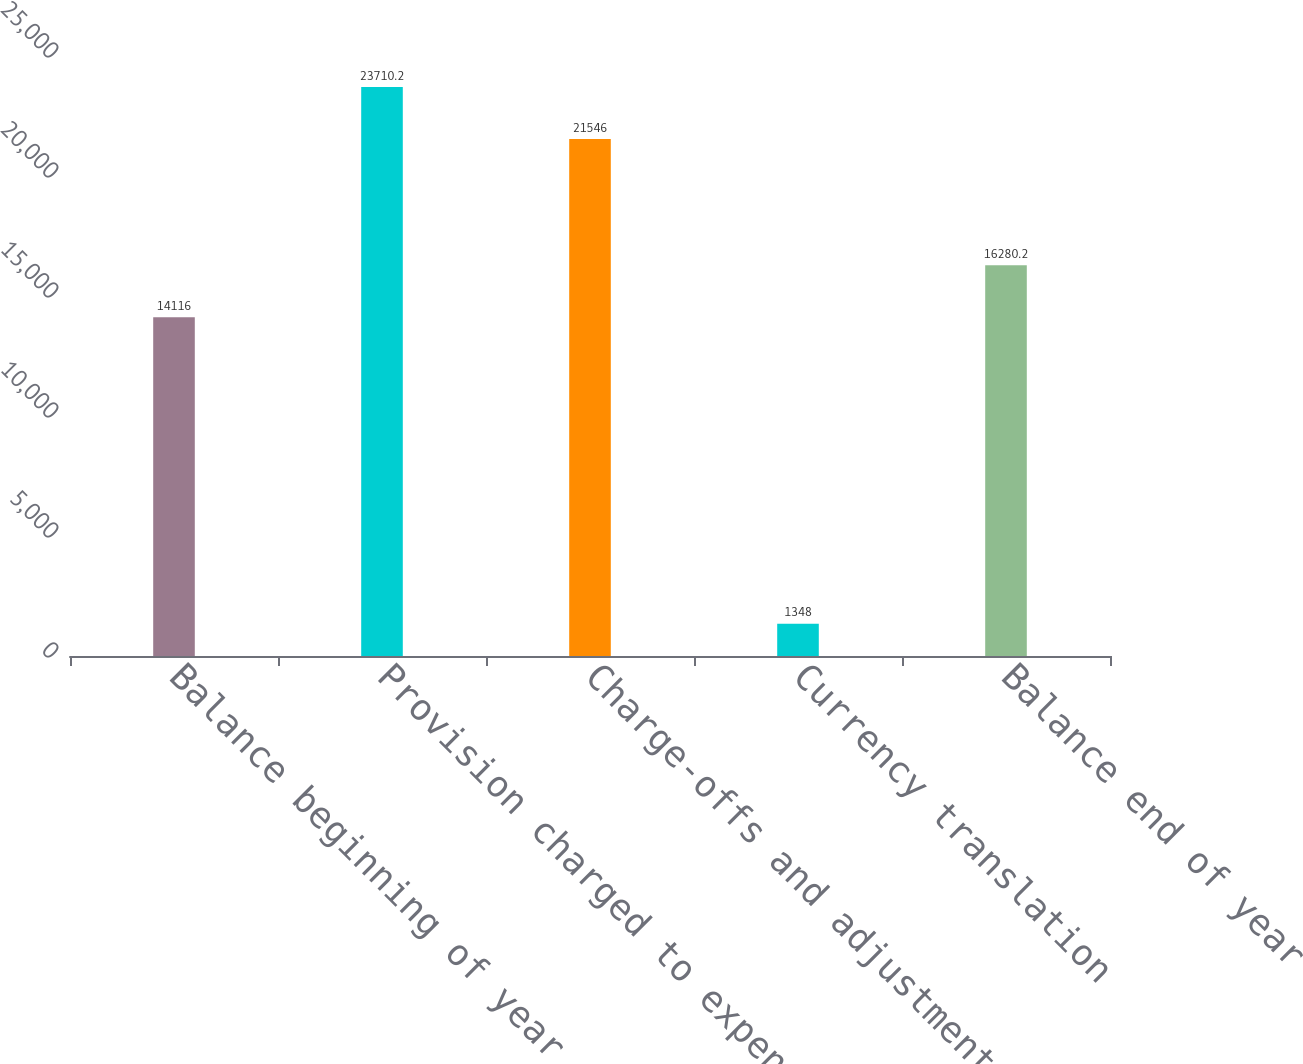Convert chart. <chart><loc_0><loc_0><loc_500><loc_500><bar_chart><fcel>Balance beginning of year<fcel>Provision charged to expense<fcel>Charge-offs and adjustments<fcel>Currency translation<fcel>Balance end of year<nl><fcel>14116<fcel>23710.2<fcel>21546<fcel>1348<fcel>16280.2<nl></chart> 